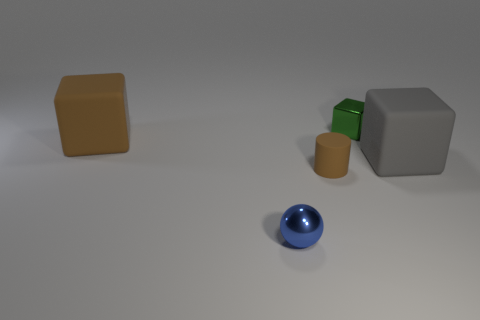Add 2 brown matte things. How many objects exist? 7 Subtract all spheres. How many objects are left? 4 Subtract all gray objects. Subtract all small blue things. How many objects are left? 3 Add 4 green metallic objects. How many green metallic objects are left? 5 Add 3 large brown metal cubes. How many large brown metal cubes exist? 3 Subtract 0 green balls. How many objects are left? 5 